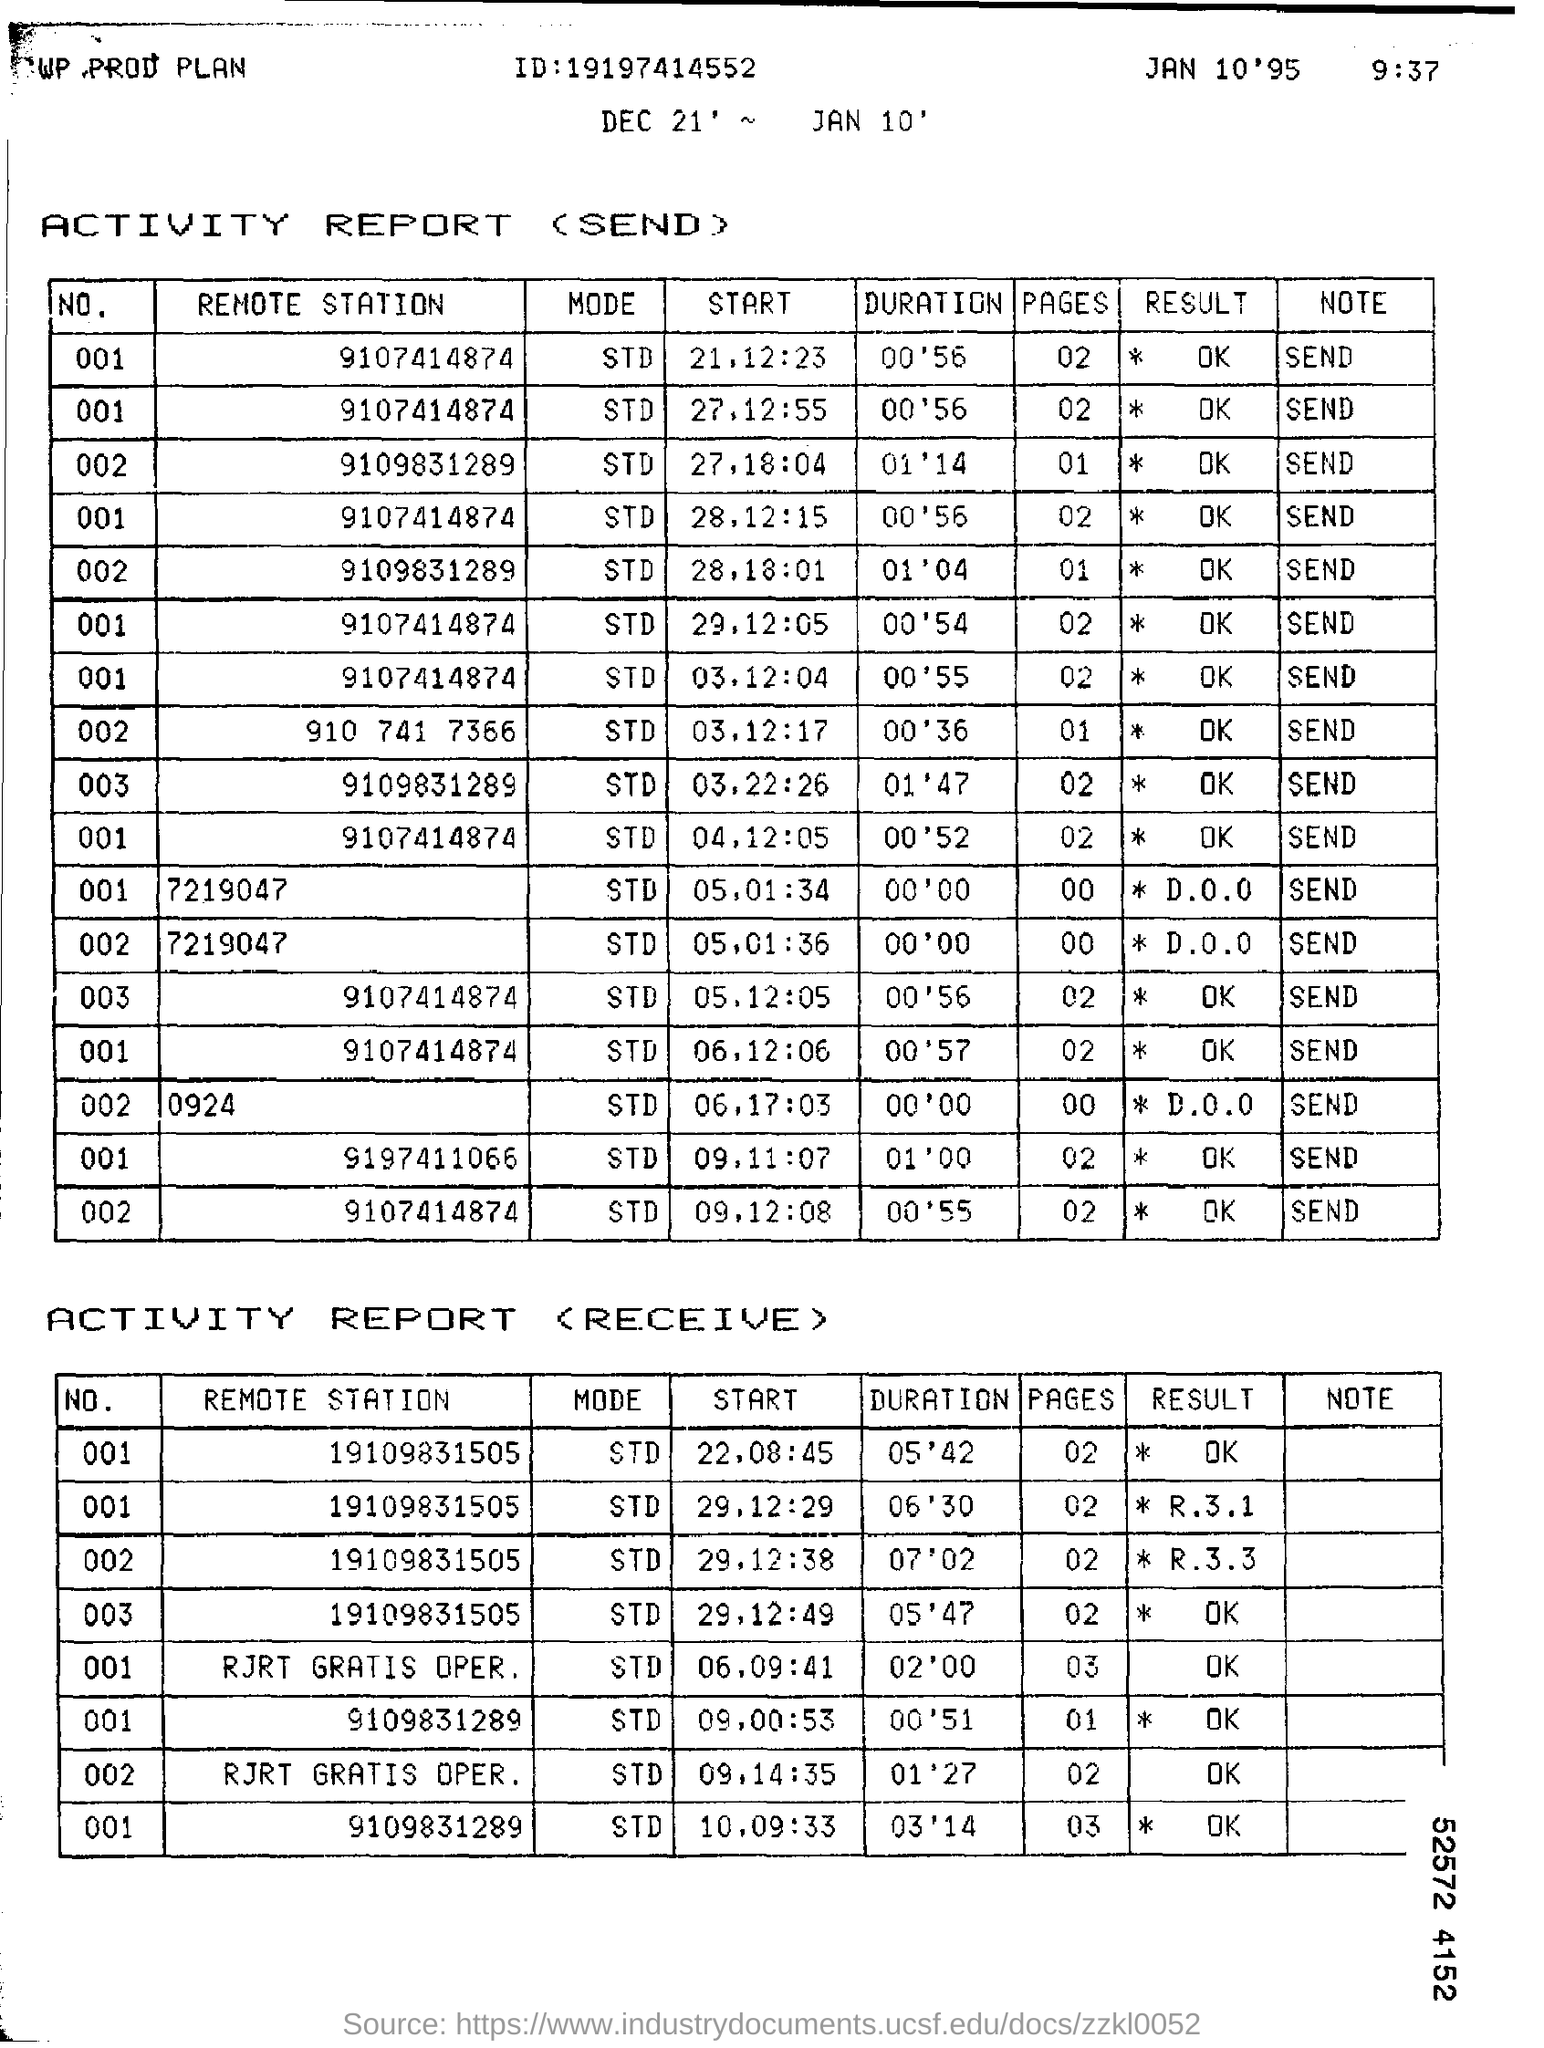What is the result for remote station 9107414874?
Your answer should be very brief. * OK. 